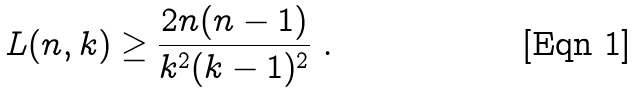<formula> <loc_0><loc_0><loc_500><loc_500>L ( n , k ) \geq \frac { 2 n ( n - 1 ) } { k ^ { 2 } ( k - 1 ) ^ { 2 } } \ .</formula> 